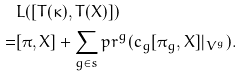<formula> <loc_0><loc_0><loc_500><loc_500>& L ( [ T ( \kappa ) , T ( X ) ] ) \\ = & [ \pi , X ] + \sum _ { g \in s } p r ^ { g } ( c _ { g } [ \pi _ { g } , X ] | _ { V ^ { g } } ) .</formula> 